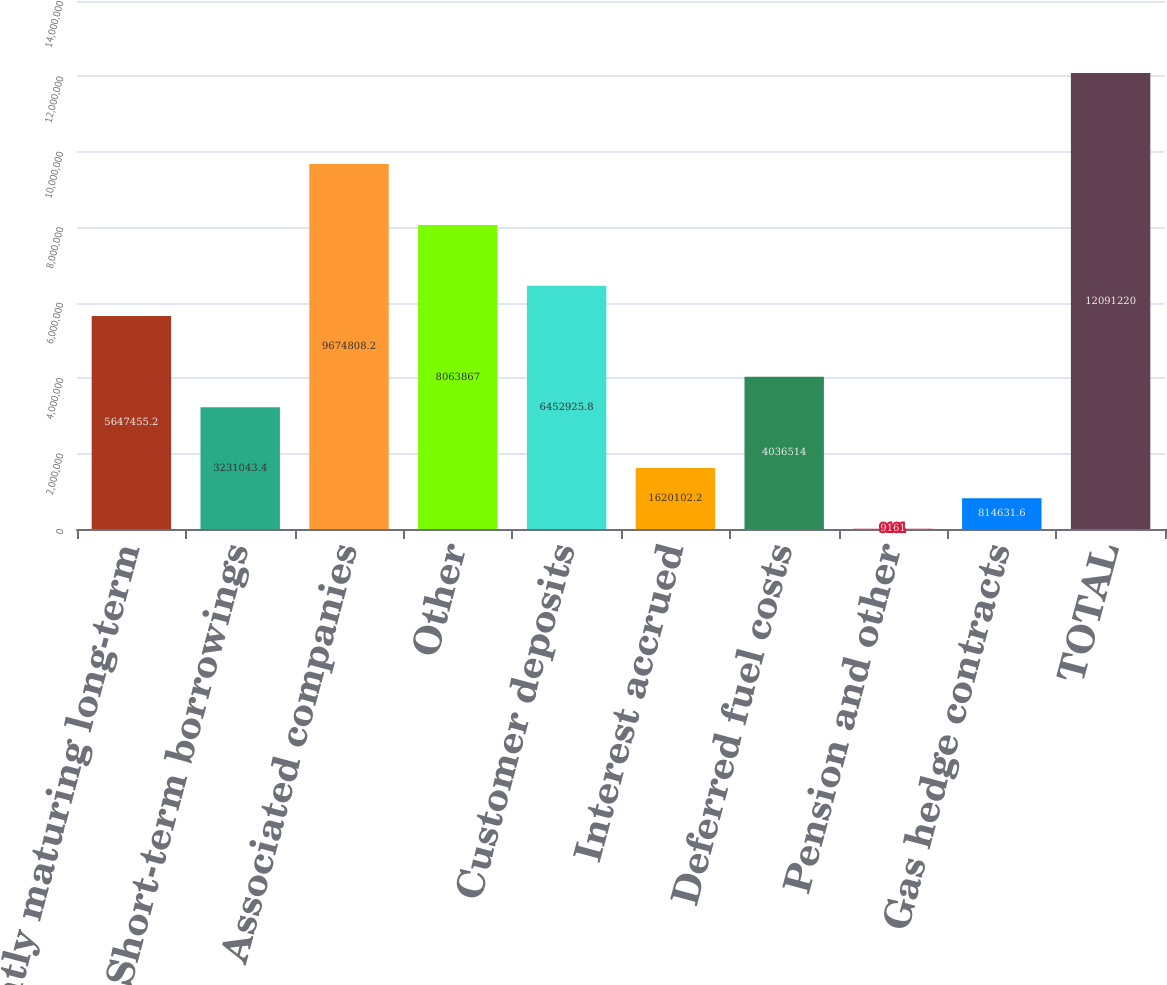<chart> <loc_0><loc_0><loc_500><loc_500><bar_chart><fcel>Currently maturing long-term<fcel>Short-term borrowings<fcel>Associated companies<fcel>Other<fcel>Customer deposits<fcel>Interest accrued<fcel>Deferred fuel costs<fcel>Pension and other<fcel>Gas hedge contracts<fcel>TOTAL<nl><fcel>5.64746e+06<fcel>3.23104e+06<fcel>9.67481e+06<fcel>8.06387e+06<fcel>6.45293e+06<fcel>1.6201e+06<fcel>4.03651e+06<fcel>9161<fcel>814632<fcel>1.20912e+07<nl></chart> 